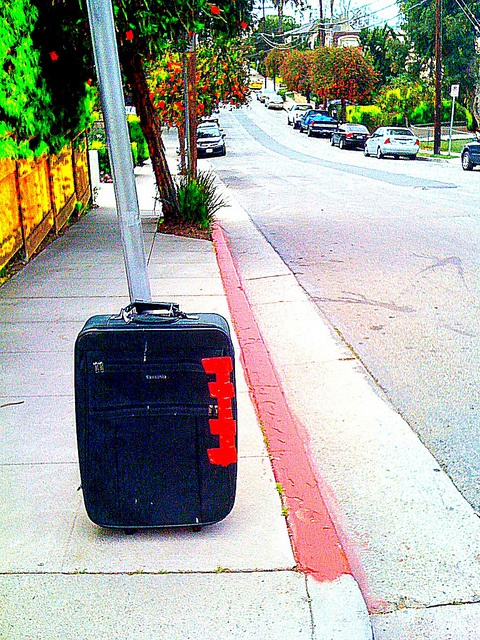Describe the objects in this image and their specific colors. I can see suitcase in lime, black, navy, red, and white tones, car in lime, white, lightblue, black, and navy tones, car in lime, black, white, navy, and cyan tones, car in lime, white, black, navy, and lightblue tones, and car in lime, white, black, navy, and lightblue tones in this image. 